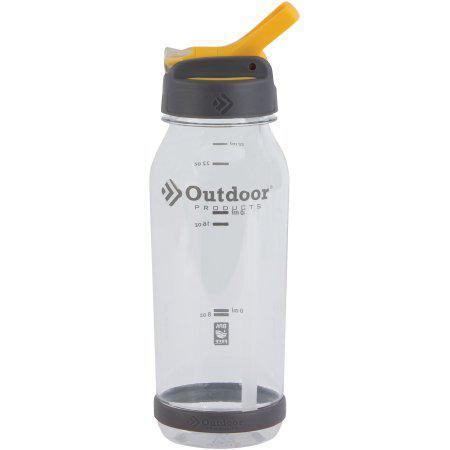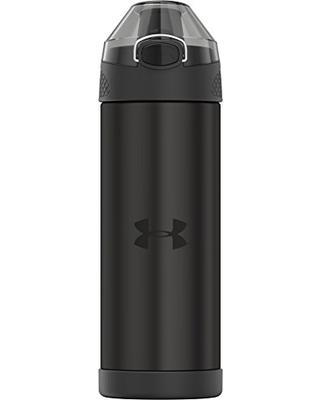The first image is the image on the left, the second image is the image on the right. Evaluate the accuracy of this statement regarding the images: "There is a single closed bottle in the right image.". Is it true? Answer yes or no. Yes. The first image is the image on the left, the second image is the image on the right. Given the left and right images, does the statement "At least one of the water bottles has other objects next to it." hold true? Answer yes or no. No. 